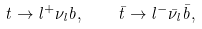Convert formula to latex. <formula><loc_0><loc_0><loc_500><loc_500>t \to l ^ { + } \nu _ { l } b , \quad \bar { t } \to l ^ { - } \bar { \nu } _ { l } \bar { b } ,</formula> 